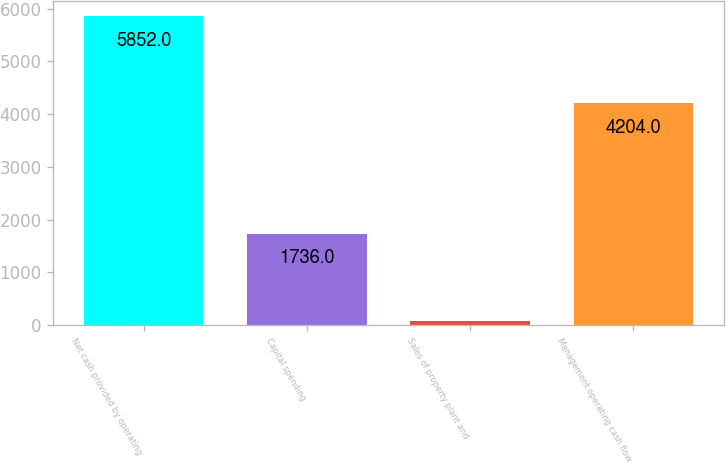<chart> <loc_0><loc_0><loc_500><loc_500><bar_chart><fcel>Net cash provided by operating<fcel>Capital spending<fcel>Sales of property plant and<fcel>Management operating cash flow<nl><fcel>5852<fcel>1736<fcel>88<fcel>4204<nl></chart> 